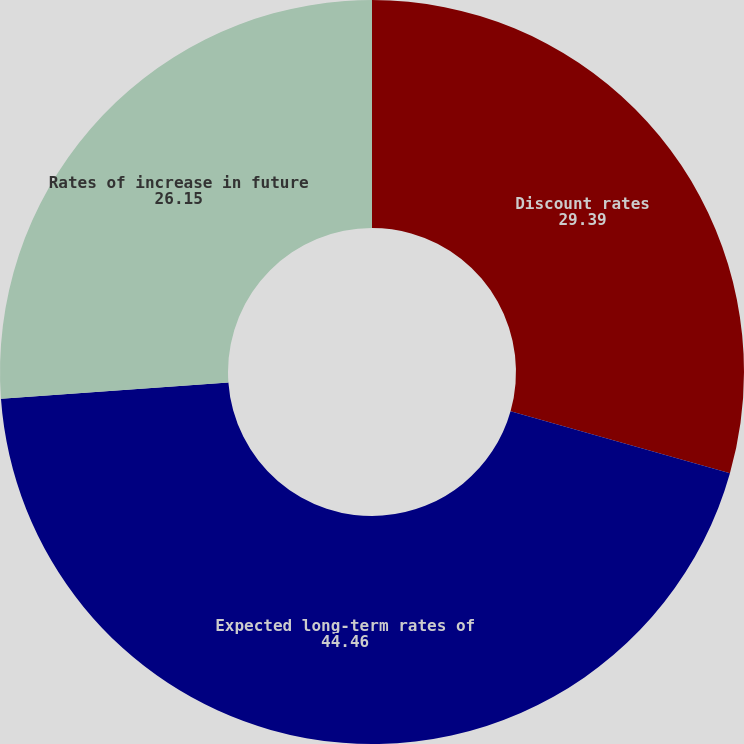<chart> <loc_0><loc_0><loc_500><loc_500><pie_chart><fcel>Discount rates<fcel>Expected long-term rates of<fcel>Rates of increase in future<nl><fcel>29.39%<fcel>44.46%<fcel>26.15%<nl></chart> 